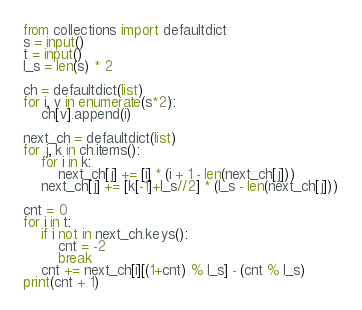Convert code to text. <code><loc_0><loc_0><loc_500><loc_500><_Python_>from collections import defaultdict
s = input()
t = input()
l_s = len(s) * 2

ch = defaultdict(list)
for i, v in enumerate(s*2):
    ch[v].append(i)

next_ch = defaultdict(list)
for j, k in ch.items():
    for i in k:
        next_ch[j] += [i] * (i + 1 - len(next_ch[j]))
    next_ch[j] += [k[-1]+l_s//2] * (l_s - len(next_ch[j]))

cnt = 0
for i in t:
    if i not in next_ch.keys():
        cnt = -2
        break
    cnt += next_ch[i][(1+cnt) % l_s] - (cnt % l_s)
print(cnt + 1)


</code> 